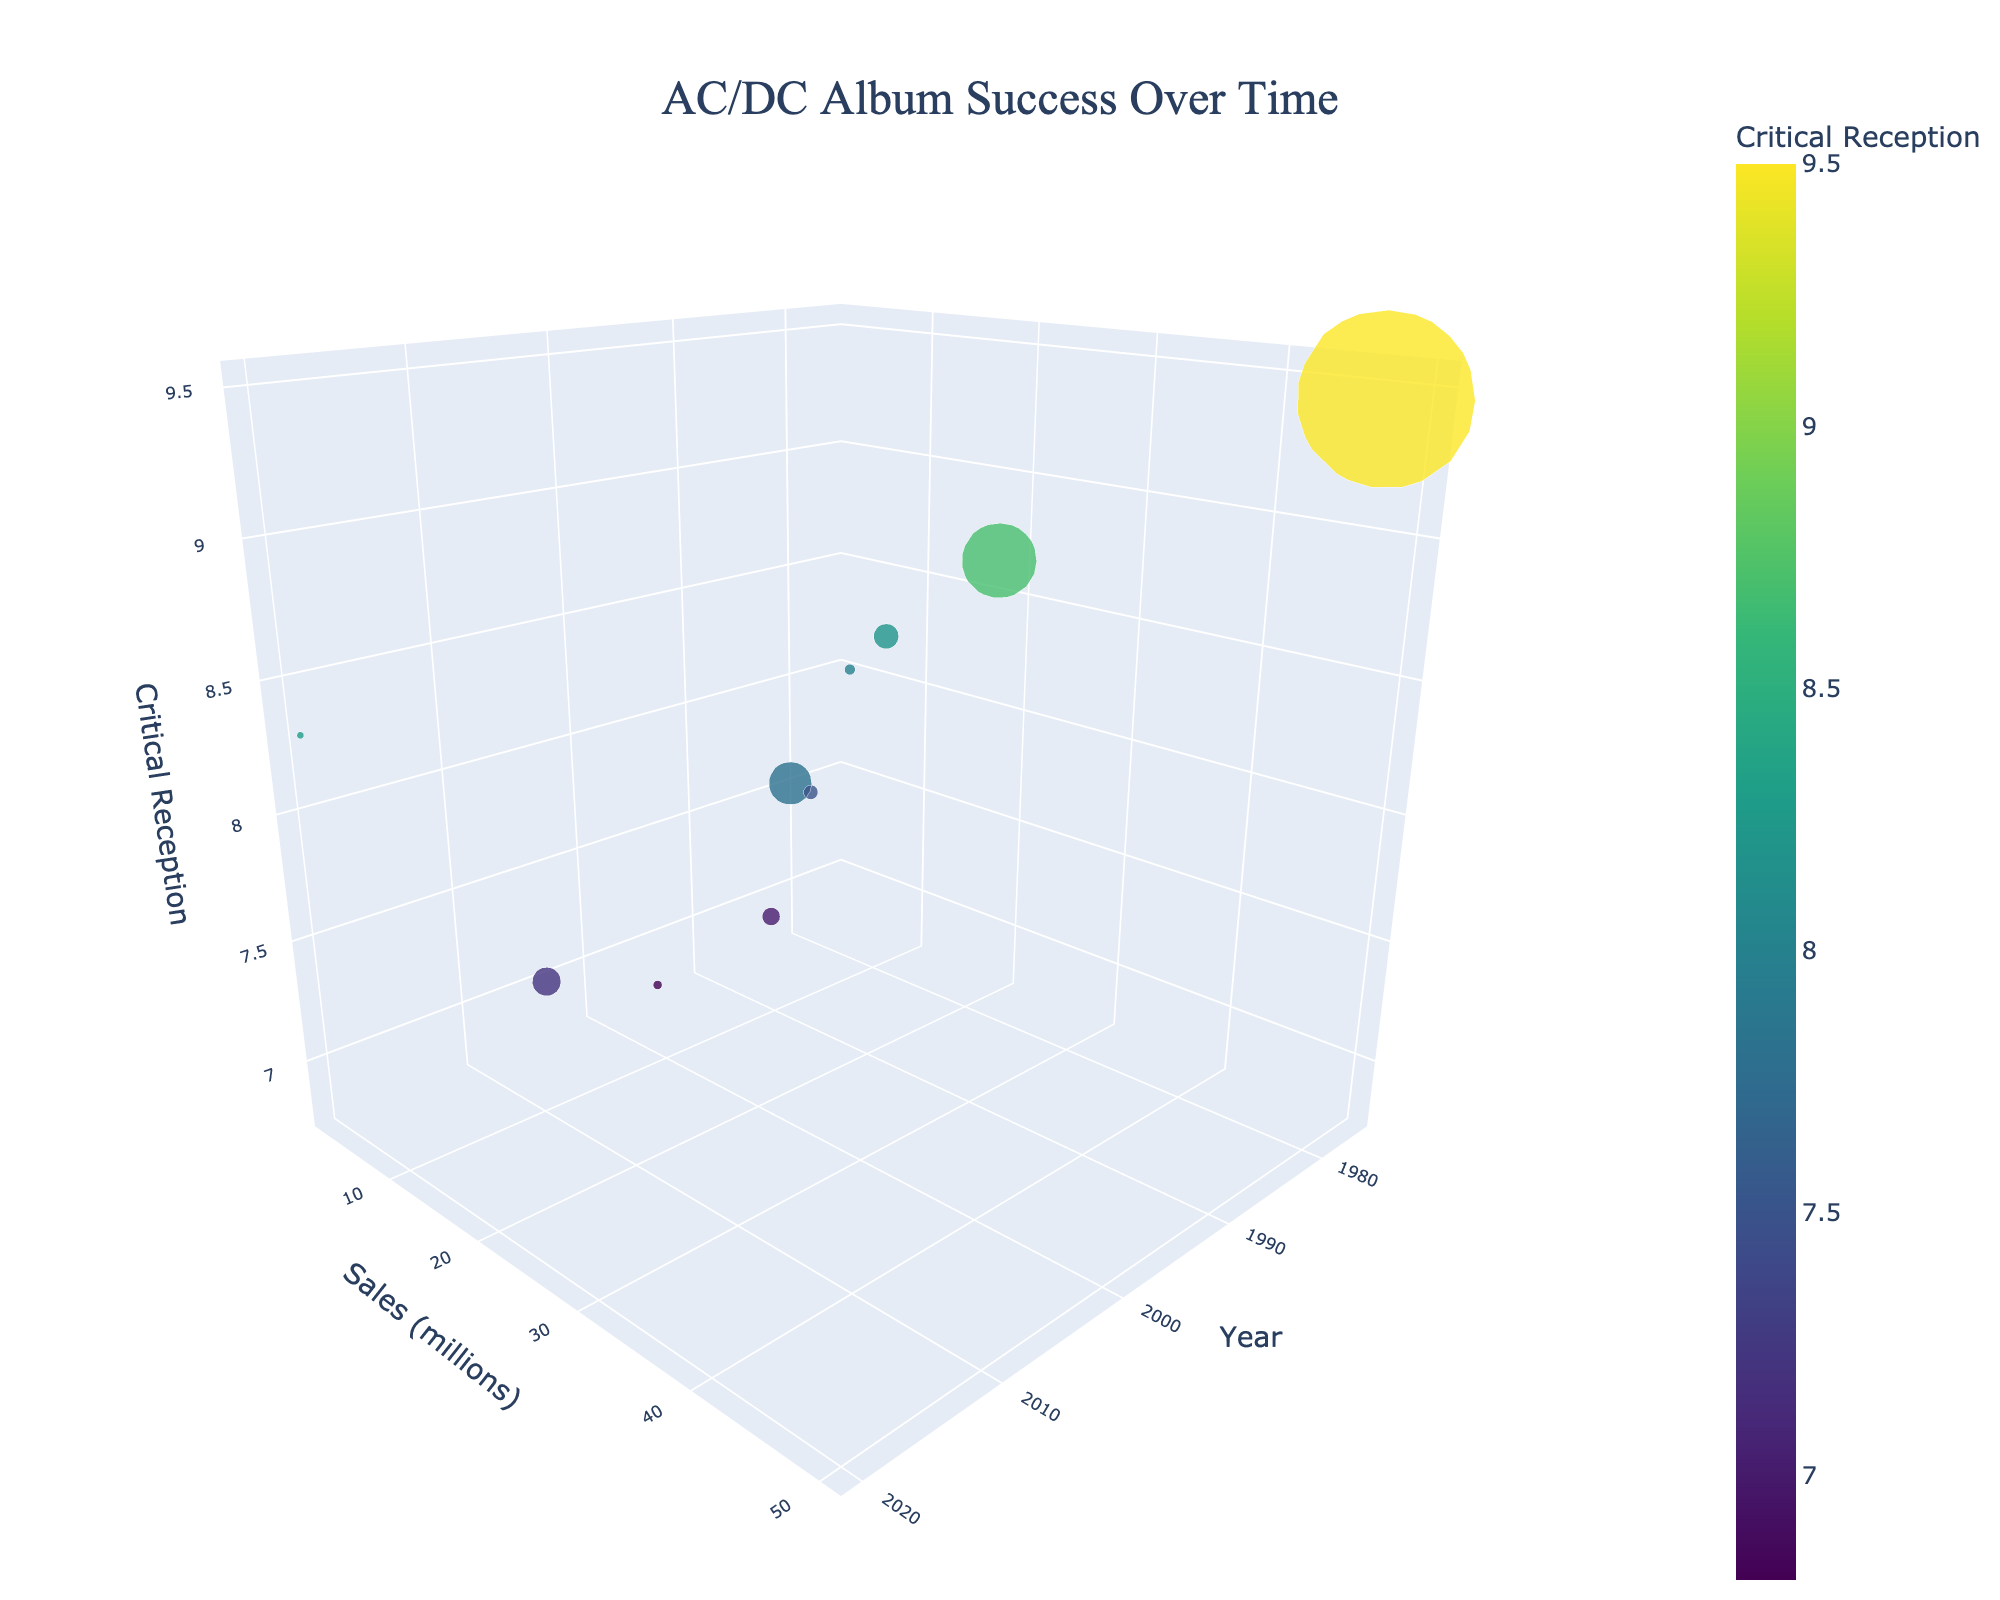What is the title of the chart? The title of the chart is always located at the top and is typically larger and bolder than other text elements. It helps identify what the chart is about.
Answer: AC/DC Album Success Over Time How many albums are represented in the chart? Count the number of bubbles in the 3D bubble chart. Each bubble represents one album.
Answer: 10 What is the highest album sales value represented? Identify the bubble that is placed at the highest position on the sales (millions) axis. Verify its numerical value from the axis label.
Answer: 50 million Which album has the highest critical reception score? Look for the highest point on the critical reception axis and note the text label associated with that bubble.
Answer: Back in Black How many albums have sales greater than 10 million? Identify bubbles that are positioned above the 10 million mark on the sales axis and count them.
Answer: 3 Which album has the smallest bubble size, and what are its sales? The bubble size is proportional to sales. Identify the smallest bubble and check its sales value.
Answer: Power Up, 2 million What’s the average sales value of the albums released in the 1970s? Locate the bubbles from the 1970s, sum their sales values, and divide by the number of these albums.
Answer: (21 + 7 + 3) / 3 = 10.33 million Which album has the highest critical reception but the lowest sales, and what are these values? Look for the bubble with the highest critical reception and identify if it also has the lowest sales. Confirm the values from the bubble's position on each axis.
Answer: Back in Black has the highest critical reception of 9.5 but not the lowest sales; lowest sales are 2 million Compare the critical reception and sales of "High Voltage" and "Ballbreaker." Which has better reviews and higher sales? Identify the bubbles labeled High Voltage and Ballbreaker, compare their positions on the critical reception and sales axes.
Answer: High Voltage has better reviews and higher sales What trend can you infer about the relationship between album release year and sales? Observe the general placement of bubbles along the year and sales axes to identify any patterns.
Answer: Older albums generally have higher sales 